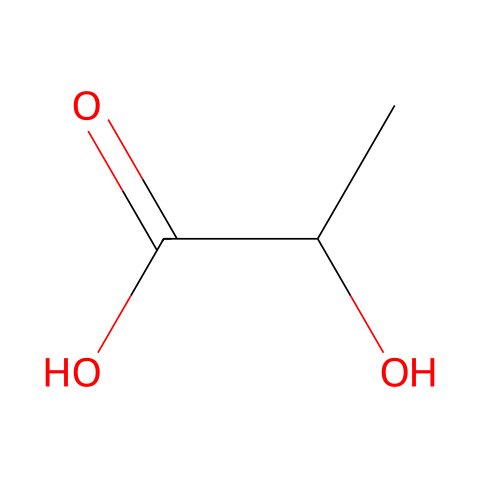What is the common name of this chemical? The SMILES representation shows the structure of lactic acid. The common name is often directly derived from its known use in food, particularly in yogurt.
Answer: lactic acid How many carbon atoms are present in lactic acid? By analyzing the SMILES notation, we find that there are three carbon atoms (C) represented in the structure. Each "C" corresponds to a carbon atom in the molecule.
Answer: 3 What type of functional group is present in lactic acid? The structure contains a carboxylic acid group (-COOH), which is a characteristic functional group for acids. This can be seen from the presence of the carbon atom double-bonded to oxygen and single-bonded to -OH.
Answer: carboxylic acid How many hydrogen atoms are in lactic acid? From the SMILES structure, we can deduce the total number of hydrogens. Each carbon has three hydrogens from one, one hydrogen from the -OH group, and two from the other carbon making a total of six.
Answer: 6 Is lactic acid a strong or weak acid? Lactic acid is classified as a weak acid because it does not fully dissociate in solution. This is evident from its structure, which lacks a highly electronegative element capable of fully donating a proton.
Answer: weak What happens to lactic acid in yogurt fermentation? During yogurt fermentation, lactic acid is produced by the fermentation action of bacteria on lactose, which indicates its role in the fermentation process. This is fundamental to the production of yogurt.
Answer: produced 